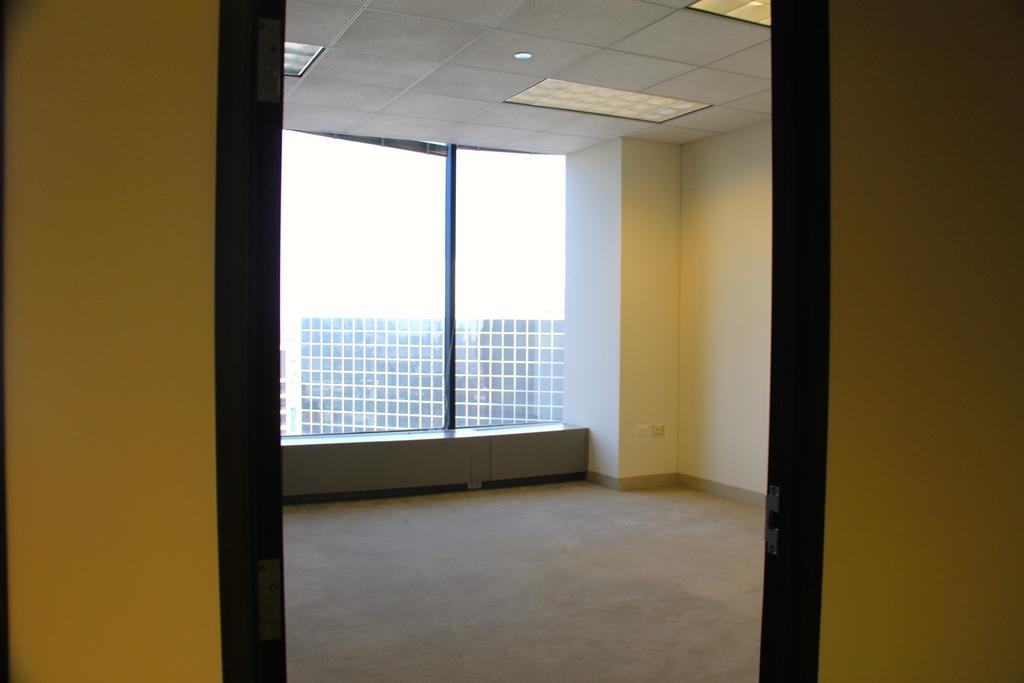Can you describe this image briefly? In this image, we can see a room and there are some yellow color walls, there is a glass window and in the background we can see a building. 